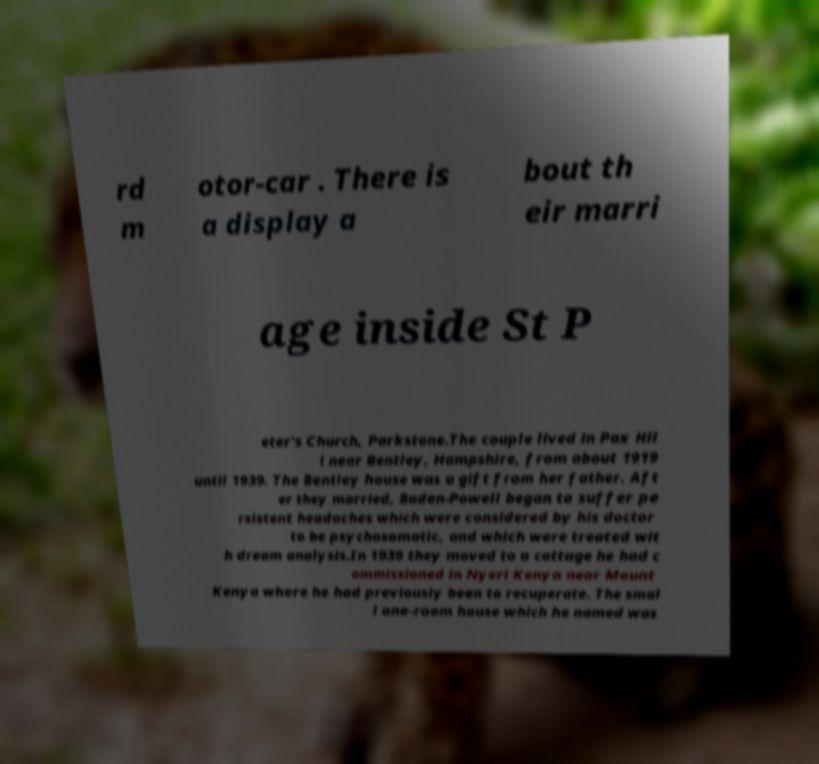There's text embedded in this image that I need extracted. Can you transcribe it verbatim? rd m otor-car . There is a display a bout th eir marri age inside St P eter's Church, Parkstone.The couple lived in Pax Hil l near Bentley, Hampshire, from about 1919 until 1939. The Bentley house was a gift from her father. Aft er they married, Baden-Powell began to suffer pe rsistent headaches which were considered by his doctor to be psychosomatic, and which were treated wit h dream analysis.In 1939 they moved to a cottage he had c ommissioned in Nyeri Kenya near Mount Kenya where he had previously been to recuperate. The smal l one-room house which he named was 